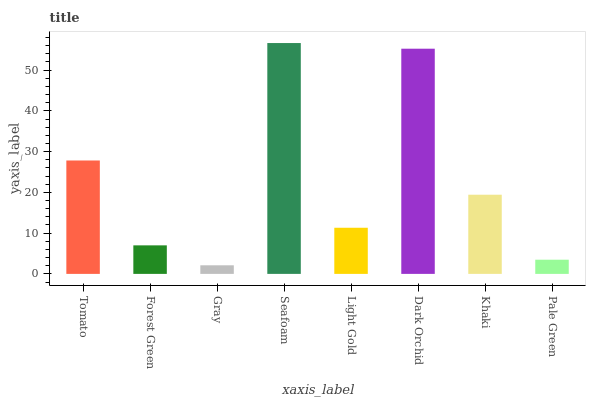Is Gray the minimum?
Answer yes or no. Yes. Is Seafoam the maximum?
Answer yes or no. Yes. Is Forest Green the minimum?
Answer yes or no. No. Is Forest Green the maximum?
Answer yes or no. No. Is Tomato greater than Forest Green?
Answer yes or no. Yes. Is Forest Green less than Tomato?
Answer yes or no. Yes. Is Forest Green greater than Tomato?
Answer yes or no. No. Is Tomato less than Forest Green?
Answer yes or no. No. Is Khaki the high median?
Answer yes or no. Yes. Is Light Gold the low median?
Answer yes or no. Yes. Is Light Gold the high median?
Answer yes or no. No. Is Tomato the low median?
Answer yes or no. No. 